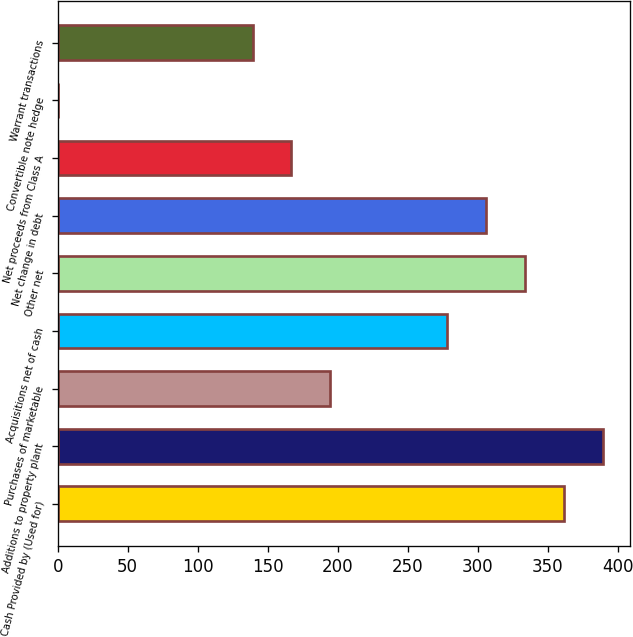Convert chart to OTSL. <chart><loc_0><loc_0><loc_500><loc_500><bar_chart><fcel>Cash Provided by (Used for)<fcel>Additions to property plant<fcel>Purchases of marketable<fcel>Acquisitions net of cash<fcel>Other net<fcel>Net change in debt<fcel>Net proceeds from Class A<fcel>Convertible note hedge<fcel>Warrant transactions<nl><fcel>361.27<fcel>389.04<fcel>194.65<fcel>277.96<fcel>333.5<fcel>305.73<fcel>166.88<fcel>0.26<fcel>139.11<nl></chart> 